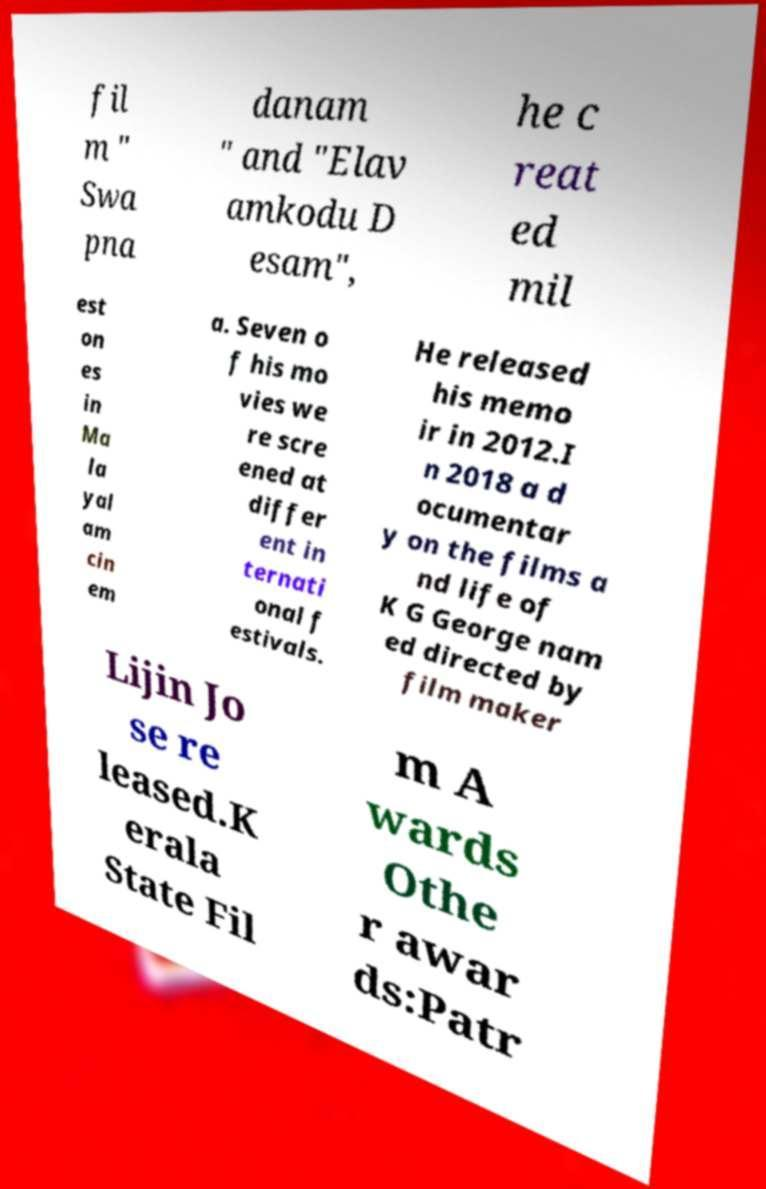Can you accurately transcribe the text from the provided image for me? fil m " Swa pna danam " and "Elav amkodu D esam", he c reat ed mil est on es in Ma la yal am cin em a. Seven o f his mo vies we re scre ened at differ ent in ternati onal f estivals. He released his memo ir in 2012.I n 2018 a d ocumentar y on the films a nd life of K G George nam ed directed by film maker Lijin Jo se re leased.K erala State Fil m A wards Othe r awar ds:Patr 